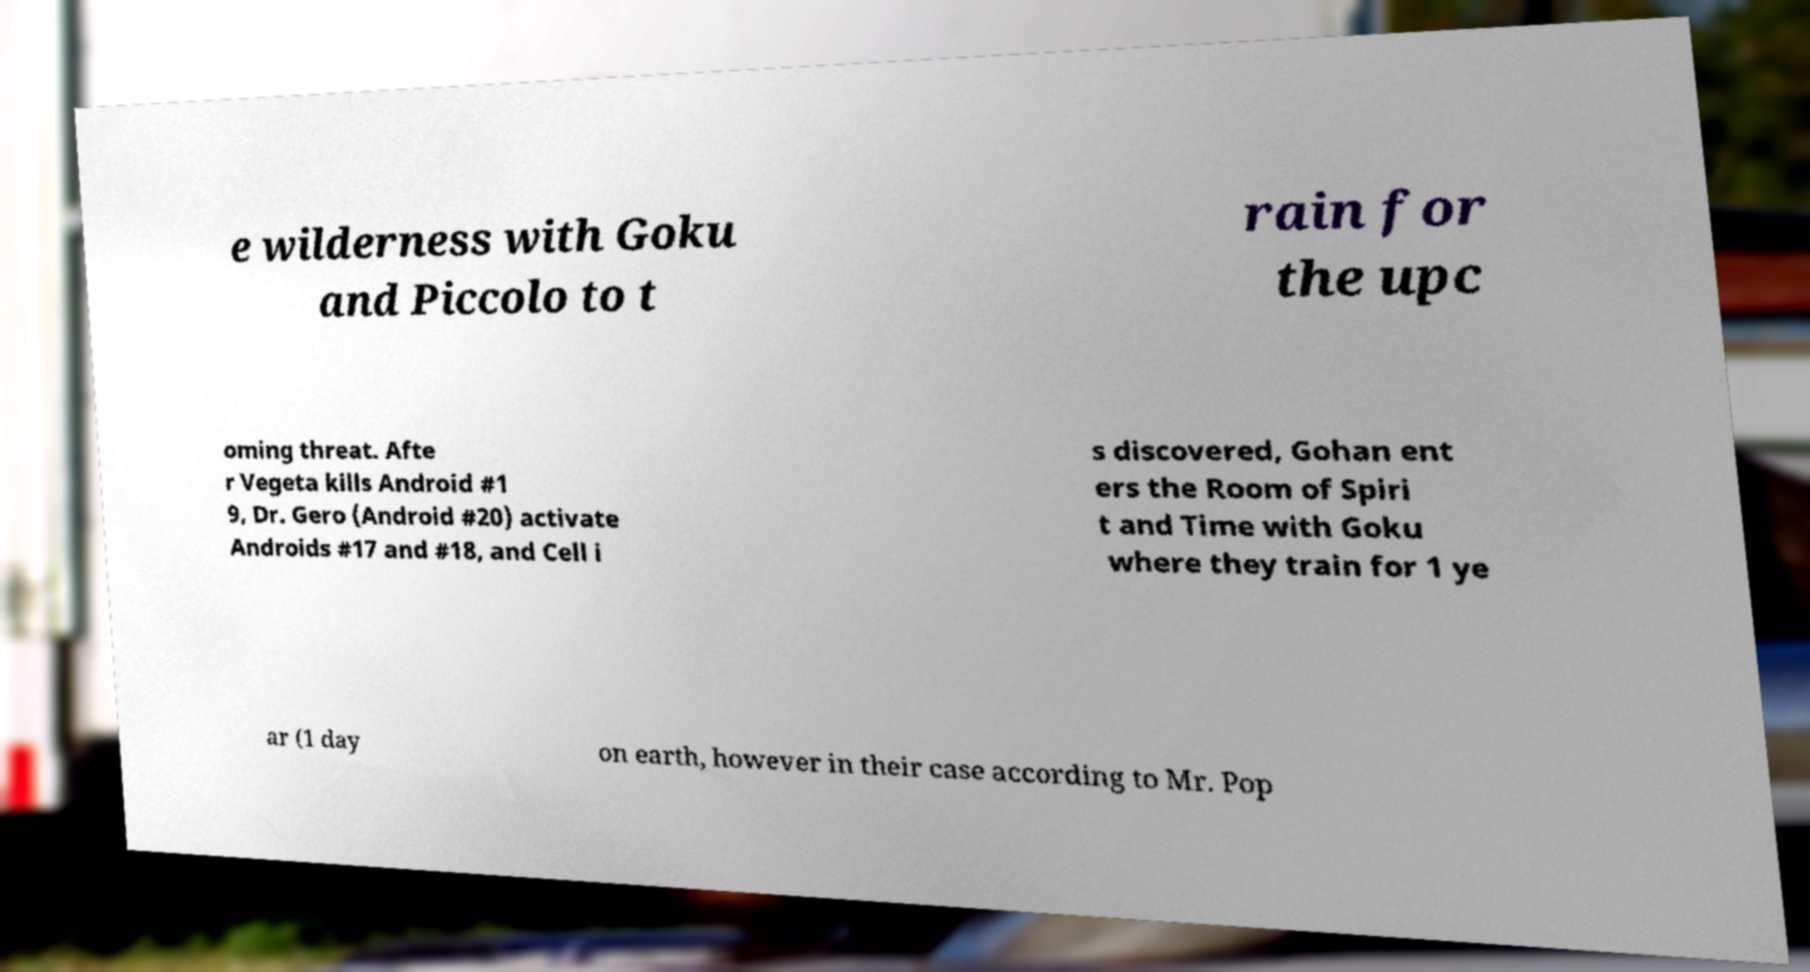Could you assist in decoding the text presented in this image and type it out clearly? e wilderness with Goku and Piccolo to t rain for the upc oming threat. Afte r Vegeta kills Android #1 9, Dr. Gero (Android #20) activate Androids #17 and #18, and Cell i s discovered, Gohan ent ers the Room of Spiri t and Time with Goku where they train for 1 ye ar (1 day on earth, however in their case according to Mr. Pop 